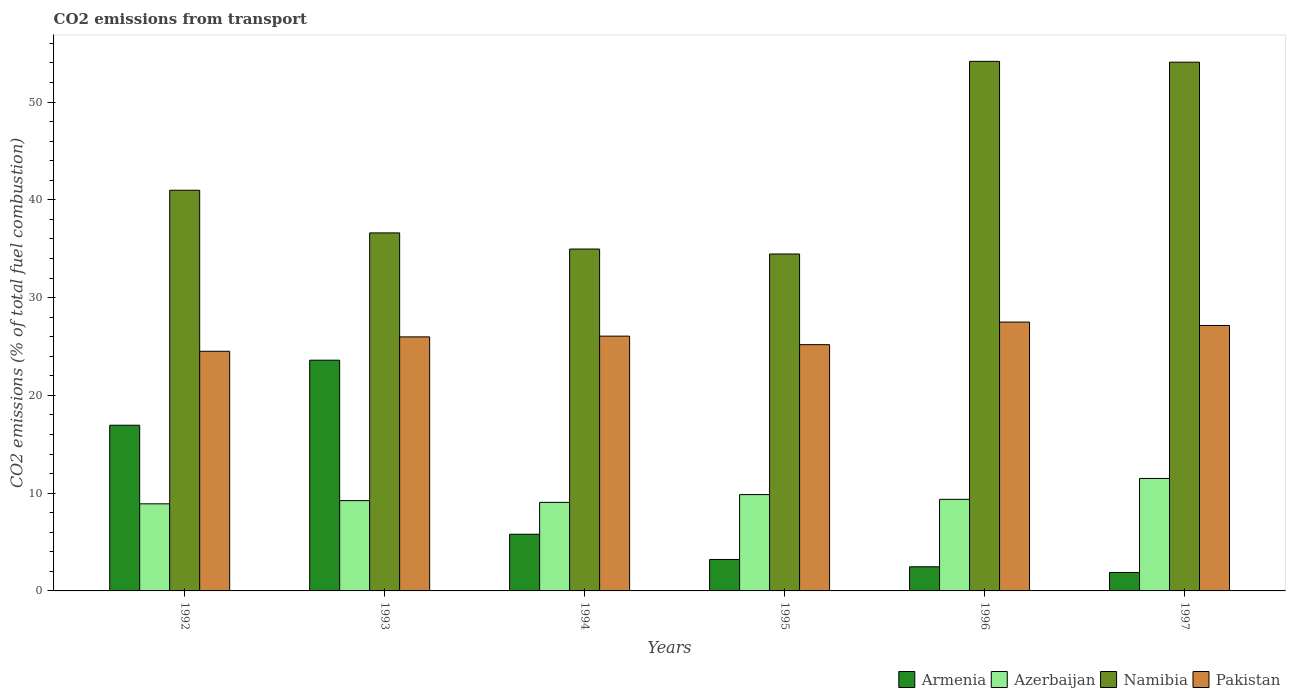How many different coloured bars are there?
Provide a succinct answer. 4. Are the number of bars per tick equal to the number of legend labels?
Make the answer very short. Yes. Are the number of bars on each tick of the X-axis equal?
Make the answer very short. Yes. How many bars are there on the 5th tick from the left?
Provide a succinct answer. 4. What is the total CO2 emitted in Azerbaijan in 1995?
Provide a short and direct response. 9.85. Across all years, what is the maximum total CO2 emitted in Azerbaijan?
Make the answer very short. 11.5. Across all years, what is the minimum total CO2 emitted in Namibia?
Provide a succinct answer. 34.46. In which year was the total CO2 emitted in Armenia minimum?
Offer a terse response. 1997. What is the total total CO2 emitted in Armenia in the graph?
Keep it short and to the point. 53.92. What is the difference between the total CO2 emitted in Pakistan in 1993 and that in 1997?
Give a very brief answer. -1.17. What is the difference between the total CO2 emitted in Namibia in 1996 and the total CO2 emitted in Azerbaijan in 1994?
Ensure brevity in your answer.  45.11. What is the average total CO2 emitted in Namibia per year?
Your answer should be very brief. 42.55. In the year 1995, what is the difference between the total CO2 emitted in Pakistan and total CO2 emitted in Namibia?
Offer a very short reply. -9.27. In how many years, is the total CO2 emitted in Pakistan greater than 54?
Ensure brevity in your answer.  0. What is the ratio of the total CO2 emitted in Armenia in 1993 to that in 1994?
Keep it short and to the point. 4.07. Is the total CO2 emitted in Namibia in 1993 less than that in 1995?
Give a very brief answer. No. What is the difference between the highest and the second highest total CO2 emitted in Namibia?
Keep it short and to the point. 0.09. What is the difference between the highest and the lowest total CO2 emitted in Armenia?
Offer a terse response. 21.71. What does the 1st bar from the left in 1994 represents?
Provide a succinct answer. Armenia. What does the 2nd bar from the right in 1997 represents?
Make the answer very short. Namibia. How many years are there in the graph?
Make the answer very short. 6. Does the graph contain any zero values?
Offer a terse response. No. Does the graph contain grids?
Provide a short and direct response. No. Where does the legend appear in the graph?
Keep it short and to the point. Bottom right. What is the title of the graph?
Keep it short and to the point. CO2 emissions from transport. What is the label or title of the Y-axis?
Your response must be concise. CO2 emissions (% of total fuel combustion). What is the CO2 emissions (% of total fuel combustion) in Armenia in 1992?
Make the answer very short. 16.95. What is the CO2 emissions (% of total fuel combustion) in Azerbaijan in 1992?
Keep it short and to the point. 8.91. What is the CO2 emissions (% of total fuel combustion) of Namibia in 1992?
Offer a terse response. 40.98. What is the CO2 emissions (% of total fuel combustion) of Pakistan in 1992?
Provide a short and direct response. 24.51. What is the CO2 emissions (% of total fuel combustion) of Armenia in 1993?
Provide a short and direct response. 23.6. What is the CO2 emissions (% of total fuel combustion) in Azerbaijan in 1993?
Keep it short and to the point. 9.24. What is the CO2 emissions (% of total fuel combustion) in Namibia in 1993?
Keep it short and to the point. 36.62. What is the CO2 emissions (% of total fuel combustion) of Pakistan in 1993?
Your answer should be compact. 25.98. What is the CO2 emissions (% of total fuel combustion) in Armenia in 1994?
Provide a succinct answer. 5.8. What is the CO2 emissions (% of total fuel combustion) in Azerbaijan in 1994?
Offer a terse response. 9.06. What is the CO2 emissions (% of total fuel combustion) in Namibia in 1994?
Make the answer very short. 34.97. What is the CO2 emissions (% of total fuel combustion) of Pakistan in 1994?
Keep it short and to the point. 26.06. What is the CO2 emissions (% of total fuel combustion) of Armenia in 1995?
Your answer should be very brief. 3.22. What is the CO2 emissions (% of total fuel combustion) in Azerbaijan in 1995?
Your answer should be very brief. 9.85. What is the CO2 emissions (% of total fuel combustion) of Namibia in 1995?
Your response must be concise. 34.46. What is the CO2 emissions (% of total fuel combustion) of Pakistan in 1995?
Your answer should be very brief. 25.19. What is the CO2 emissions (% of total fuel combustion) in Armenia in 1996?
Keep it short and to the point. 2.47. What is the CO2 emissions (% of total fuel combustion) in Azerbaijan in 1996?
Give a very brief answer. 9.37. What is the CO2 emissions (% of total fuel combustion) in Namibia in 1996?
Your answer should be compact. 54.17. What is the CO2 emissions (% of total fuel combustion) of Pakistan in 1996?
Your answer should be compact. 27.5. What is the CO2 emissions (% of total fuel combustion) in Armenia in 1997?
Ensure brevity in your answer.  1.89. What is the CO2 emissions (% of total fuel combustion) in Azerbaijan in 1997?
Offer a very short reply. 11.5. What is the CO2 emissions (% of total fuel combustion) in Namibia in 1997?
Offer a very short reply. 54.08. What is the CO2 emissions (% of total fuel combustion) of Pakistan in 1997?
Offer a terse response. 27.15. Across all years, what is the maximum CO2 emissions (% of total fuel combustion) in Armenia?
Give a very brief answer. 23.6. Across all years, what is the maximum CO2 emissions (% of total fuel combustion) of Azerbaijan?
Your answer should be very brief. 11.5. Across all years, what is the maximum CO2 emissions (% of total fuel combustion) in Namibia?
Offer a terse response. 54.17. Across all years, what is the maximum CO2 emissions (% of total fuel combustion) of Pakistan?
Keep it short and to the point. 27.5. Across all years, what is the minimum CO2 emissions (% of total fuel combustion) in Armenia?
Your answer should be very brief. 1.89. Across all years, what is the minimum CO2 emissions (% of total fuel combustion) of Azerbaijan?
Ensure brevity in your answer.  8.91. Across all years, what is the minimum CO2 emissions (% of total fuel combustion) in Namibia?
Your answer should be compact. 34.46. Across all years, what is the minimum CO2 emissions (% of total fuel combustion) in Pakistan?
Provide a succinct answer. 24.51. What is the total CO2 emissions (% of total fuel combustion) of Armenia in the graph?
Ensure brevity in your answer.  53.92. What is the total CO2 emissions (% of total fuel combustion) of Azerbaijan in the graph?
Your response must be concise. 57.93. What is the total CO2 emissions (% of total fuel combustion) in Namibia in the graph?
Your answer should be compact. 255.28. What is the total CO2 emissions (% of total fuel combustion) in Pakistan in the graph?
Offer a very short reply. 156.4. What is the difference between the CO2 emissions (% of total fuel combustion) in Armenia in 1992 and that in 1993?
Provide a short and direct response. -6.65. What is the difference between the CO2 emissions (% of total fuel combustion) in Azerbaijan in 1992 and that in 1993?
Your answer should be compact. -0.33. What is the difference between the CO2 emissions (% of total fuel combustion) of Namibia in 1992 and that in 1993?
Your answer should be very brief. 4.36. What is the difference between the CO2 emissions (% of total fuel combustion) of Pakistan in 1992 and that in 1993?
Your response must be concise. -1.47. What is the difference between the CO2 emissions (% of total fuel combustion) of Armenia in 1992 and that in 1994?
Provide a short and direct response. 11.15. What is the difference between the CO2 emissions (% of total fuel combustion) of Azerbaijan in 1992 and that in 1994?
Provide a short and direct response. -0.15. What is the difference between the CO2 emissions (% of total fuel combustion) in Namibia in 1992 and that in 1994?
Offer a terse response. 6.01. What is the difference between the CO2 emissions (% of total fuel combustion) of Pakistan in 1992 and that in 1994?
Provide a succinct answer. -1.55. What is the difference between the CO2 emissions (% of total fuel combustion) of Armenia in 1992 and that in 1995?
Your answer should be very brief. 13.73. What is the difference between the CO2 emissions (% of total fuel combustion) of Azerbaijan in 1992 and that in 1995?
Give a very brief answer. -0.94. What is the difference between the CO2 emissions (% of total fuel combustion) in Namibia in 1992 and that in 1995?
Make the answer very short. 6.52. What is the difference between the CO2 emissions (% of total fuel combustion) in Pakistan in 1992 and that in 1995?
Your answer should be very brief. -0.68. What is the difference between the CO2 emissions (% of total fuel combustion) in Armenia in 1992 and that in 1996?
Your answer should be very brief. 14.48. What is the difference between the CO2 emissions (% of total fuel combustion) in Azerbaijan in 1992 and that in 1996?
Offer a terse response. -0.46. What is the difference between the CO2 emissions (% of total fuel combustion) of Namibia in 1992 and that in 1996?
Offer a very short reply. -13.18. What is the difference between the CO2 emissions (% of total fuel combustion) in Pakistan in 1992 and that in 1996?
Make the answer very short. -2.99. What is the difference between the CO2 emissions (% of total fuel combustion) in Armenia in 1992 and that in 1997?
Provide a short and direct response. 15.06. What is the difference between the CO2 emissions (% of total fuel combustion) in Azerbaijan in 1992 and that in 1997?
Your response must be concise. -2.6. What is the difference between the CO2 emissions (% of total fuel combustion) in Namibia in 1992 and that in 1997?
Ensure brevity in your answer.  -13.1. What is the difference between the CO2 emissions (% of total fuel combustion) of Pakistan in 1992 and that in 1997?
Offer a terse response. -2.64. What is the difference between the CO2 emissions (% of total fuel combustion) in Armenia in 1993 and that in 1994?
Keep it short and to the point. 17.8. What is the difference between the CO2 emissions (% of total fuel combustion) of Azerbaijan in 1993 and that in 1994?
Your answer should be very brief. 0.18. What is the difference between the CO2 emissions (% of total fuel combustion) of Namibia in 1993 and that in 1994?
Make the answer very short. 1.65. What is the difference between the CO2 emissions (% of total fuel combustion) in Pakistan in 1993 and that in 1994?
Your answer should be very brief. -0.08. What is the difference between the CO2 emissions (% of total fuel combustion) in Armenia in 1993 and that in 1995?
Provide a short and direct response. 20.38. What is the difference between the CO2 emissions (% of total fuel combustion) in Azerbaijan in 1993 and that in 1995?
Provide a succinct answer. -0.62. What is the difference between the CO2 emissions (% of total fuel combustion) in Namibia in 1993 and that in 1995?
Ensure brevity in your answer.  2.16. What is the difference between the CO2 emissions (% of total fuel combustion) in Pakistan in 1993 and that in 1995?
Make the answer very short. 0.8. What is the difference between the CO2 emissions (% of total fuel combustion) of Armenia in 1993 and that in 1996?
Provide a short and direct response. 21.13. What is the difference between the CO2 emissions (% of total fuel combustion) in Azerbaijan in 1993 and that in 1996?
Provide a short and direct response. -0.13. What is the difference between the CO2 emissions (% of total fuel combustion) in Namibia in 1993 and that in 1996?
Offer a terse response. -17.55. What is the difference between the CO2 emissions (% of total fuel combustion) in Pakistan in 1993 and that in 1996?
Your answer should be compact. -1.51. What is the difference between the CO2 emissions (% of total fuel combustion) in Armenia in 1993 and that in 1997?
Provide a succinct answer. 21.71. What is the difference between the CO2 emissions (% of total fuel combustion) in Azerbaijan in 1993 and that in 1997?
Offer a very short reply. -2.27. What is the difference between the CO2 emissions (% of total fuel combustion) of Namibia in 1993 and that in 1997?
Provide a succinct answer. -17.46. What is the difference between the CO2 emissions (% of total fuel combustion) of Pakistan in 1993 and that in 1997?
Make the answer very short. -1.17. What is the difference between the CO2 emissions (% of total fuel combustion) in Armenia in 1994 and that in 1995?
Your answer should be very brief. 2.58. What is the difference between the CO2 emissions (% of total fuel combustion) in Azerbaijan in 1994 and that in 1995?
Provide a short and direct response. -0.79. What is the difference between the CO2 emissions (% of total fuel combustion) in Namibia in 1994 and that in 1995?
Your answer should be very brief. 0.51. What is the difference between the CO2 emissions (% of total fuel combustion) in Pakistan in 1994 and that in 1995?
Your response must be concise. 0.87. What is the difference between the CO2 emissions (% of total fuel combustion) of Armenia in 1994 and that in 1996?
Offer a very short reply. 3.33. What is the difference between the CO2 emissions (% of total fuel combustion) of Azerbaijan in 1994 and that in 1996?
Keep it short and to the point. -0.31. What is the difference between the CO2 emissions (% of total fuel combustion) of Namibia in 1994 and that in 1996?
Provide a short and direct response. -19.2. What is the difference between the CO2 emissions (% of total fuel combustion) in Pakistan in 1994 and that in 1996?
Provide a succinct answer. -1.44. What is the difference between the CO2 emissions (% of total fuel combustion) of Armenia in 1994 and that in 1997?
Your answer should be very brief. 3.91. What is the difference between the CO2 emissions (% of total fuel combustion) of Azerbaijan in 1994 and that in 1997?
Your answer should be compact. -2.45. What is the difference between the CO2 emissions (% of total fuel combustion) of Namibia in 1994 and that in 1997?
Your answer should be compact. -19.11. What is the difference between the CO2 emissions (% of total fuel combustion) of Pakistan in 1994 and that in 1997?
Provide a succinct answer. -1.09. What is the difference between the CO2 emissions (% of total fuel combustion) of Armenia in 1995 and that in 1996?
Offer a very short reply. 0.75. What is the difference between the CO2 emissions (% of total fuel combustion) in Azerbaijan in 1995 and that in 1996?
Offer a very short reply. 0.49. What is the difference between the CO2 emissions (% of total fuel combustion) in Namibia in 1995 and that in 1996?
Provide a succinct answer. -19.7. What is the difference between the CO2 emissions (% of total fuel combustion) of Pakistan in 1995 and that in 1996?
Provide a succinct answer. -2.31. What is the difference between the CO2 emissions (% of total fuel combustion) in Armenia in 1995 and that in 1997?
Your answer should be compact. 1.33. What is the difference between the CO2 emissions (% of total fuel combustion) in Azerbaijan in 1995 and that in 1997?
Make the answer very short. -1.65. What is the difference between the CO2 emissions (% of total fuel combustion) of Namibia in 1995 and that in 1997?
Offer a terse response. -19.62. What is the difference between the CO2 emissions (% of total fuel combustion) of Pakistan in 1995 and that in 1997?
Ensure brevity in your answer.  -1.96. What is the difference between the CO2 emissions (% of total fuel combustion) in Armenia in 1996 and that in 1997?
Offer a terse response. 0.58. What is the difference between the CO2 emissions (% of total fuel combustion) of Azerbaijan in 1996 and that in 1997?
Make the answer very short. -2.14. What is the difference between the CO2 emissions (% of total fuel combustion) in Namibia in 1996 and that in 1997?
Your answer should be compact. 0.09. What is the difference between the CO2 emissions (% of total fuel combustion) in Pakistan in 1996 and that in 1997?
Offer a terse response. 0.35. What is the difference between the CO2 emissions (% of total fuel combustion) in Armenia in 1992 and the CO2 emissions (% of total fuel combustion) in Azerbaijan in 1993?
Ensure brevity in your answer.  7.71. What is the difference between the CO2 emissions (% of total fuel combustion) of Armenia in 1992 and the CO2 emissions (% of total fuel combustion) of Namibia in 1993?
Ensure brevity in your answer.  -19.67. What is the difference between the CO2 emissions (% of total fuel combustion) in Armenia in 1992 and the CO2 emissions (% of total fuel combustion) in Pakistan in 1993?
Your answer should be compact. -9.04. What is the difference between the CO2 emissions (% of total fuel combustion) in Azerbaijan in 1992 and the CO2 emissions (% of total fuel combustion) in Namibia in 1993?
Offer a terse response. -27.71. What is the difference between the CO2 emissions (% of total fuel combustion) in Azerbaijan in 1992 and the CO2 emissions (% of total fuel combustion) in Pakistan in 1993?
Your response must be concise. -17.07. What is the difference between the CO2 emissions (% of total fuel combustion) of Namibia in 1992 and the CO2 emissions (% of total fuel combustion) of Pakistan in 1993?
Your response must be concise. 15. What is the difference between the CO2 emissions (% of total fuel combustion) of Armenia in 1992 and the CO2 emissions (% of total fuel combustion) of Azerbaijan in 1994?
Your response must be concise. 7.89. What is the difference between the CO2 emissions (% of total fuel combustion) in Armenia in 1992 and the CO2 emissions (% of total fuel combustion) in Namibia in 1994?
Provide a succinct answer. -18.02. What is the difference between the CO2 emissions (% of total fuel combustion) in Armenia in 1992 and the CO2 emissions (% of total fuel combustion) in Pakistan in 1994?
Provide a succinct answer. -9.11. What is the difference between the CO2 emissions (% of total fuel combustion) in Azerbaijan in 1992 and the CO2 emissions (% of total fuel combustion) in Namibia in 1994?
Make the answer very short. -26.06. What is the difference between the CO2 emissions (% of total fuel combustion) of Azerbaijan in 1992 and the CO2 emissions (% of total fuel combustion) of Pakistan in 1994?
Your response must be concise. -17.15. What is the difference between the CO2 emissions (% of total fuel combustion) in Namibia in 1992 and the CO2 emissions (% of total fuel combustion) in Pakistan in 1994?
Offer a very short reply. 14.92. What is the difference between the CO2 emissions (% of total fuel combustion) of Armenia in 1992 and the CO2 emissions (% of total fuel combustion) of Azerbaijan in 1995?
Your answer should be compact. 7.1. What is the difference between the CO2 emissions (% of total fuel combustion) in Armenia in 1992 and the CO2 emissions (% of total fuel combustion) in Namibia in 1995?
Give a very brief answer. -17.52. What is the difference between the CO2 emissions (% of total fuel combustion) of Armenia in 1992 and the CO2 emissions (% of total fuel combustion) of Pakistan in 1995?
Keep it short and to the point. -8.24. What is the difference between the CO2 emissions (% of total fuel combustion) of Azerbaijan in 1992 and the CO2 emissions (% of total fuel combustion) of Namibia in 1995?
Your answer should be very brief. -25.55. What is the difference between the CO2 emissions (% of total fuel combustion) in Azerbaijan in 1992 and the CO2 emissions (% of total fuel combustion) in Pakistan in 1995?
Offer a terse response. -16.28. What is the difference between the CO2 emissions (% of total fuel combustion) of Namibia in 1992 and the CO2 emissions (% of total fuel combustion) of Pakistan in 1995?
Ensure brevity in your answer.  15.79. What is the difference between the CO2 emissions (% of total fuel combustion) of Armenia in 1992 and the CO2 emissions (% of total fuel combustion) of Azerbaijan in 1996?
Offer a terse response. 7.58. What is the difference between the CO2 emissions (% of total fuel combustion) in Armenia in 1992 and the CO2 emissions (% of total fuel combustion) in Namibia in 1996?
Offer a very short reply. -37.22. What is the difference between the CO2 emissions (% of total fuel combustion) of Armenia in 1992 and the CO2 emissions (% of total fuel combustion) of Pakistan in 1996?
Your answer should be very brief. -10.55. What is the difference between the CO2 emissions (% of total fuel combustion) in Azerbaijan in 1992 and the CO2 emissions (% of total fuel combustion) in Namibia in 1996?
Your response must be concise. -45.26. What is the difference between the CO2 emissions (% of total fuel combustion) in Azerbaijan in 1992 and the CO2 emissions (% of total fuel combustion) in Pakistan in 1996?
Your answer should be compact. -18.59. What is the difference between the CO2 emissions (% of total fuel combustion) in Namibia in 1992 and the CO2 emissions (% of total fuel combustion) in Pakistan in 1996?
Your answer should be very brief. 13.48. What is the difference between the CO2 emissions (% of total fuel combustion) in Armenia in 1992 and the CO2 emissions (% of total fuel combustion) in Azerbaijan in 1997?
Your answer should be compact. 5.44. What is the difference between the CO2 emissions (% of total fuel combustion) of Armenia in 1992 and the CO2 emissions (% of total fuel combustion) of Namibia in 1997?
Offer a very short reply. -37.13. What is the difference between the CO2 emissions (% of total fuel combustion) of Armenia in 1992 and the CO2 emissions (% of total fuel combustion) of Pakistan in 1997?
Provide a short and direct response. -10.2. What is the difference between the CO2 emissions (% of total fuel combustion) in Azerbaijan in 1992 and the CO2 emissions (% of total fuel combustion) in Namibia in 1997?
Your answer should be very brief. -45.17. What is the difference between the CO2 emissions (% of total fuel combustion) in Azerbaijan in 1992 and the CO2 emissions (% of total fuel combustion) in Pakistan in 1997?
Ensure brevity in your answer.  -18.24. What is the difference between the CO2 emissions (% of total fuel combustion) of Namibia in 1992 and the CO2 emissions (% of total fuel combustion) of Pakistan in 1997?
Your response must be concise. 13.83. What is the difference between the CO2 emissions (% of total fuel combustion) of Armenia in 1993 and the CO2 emissions (% of total fuel combustion) of Azerbaijan in 1994?
Your answer should be very brief. 14.54. What is the difference between the CO2 emissions (% of total fuel combustion) in Armenia in 1993 and the CO2 emissions (% of total fuel combustion) in Namibia in 1994?
Offer a terse response. -11.37. What is the difference between the CO2 emissions (% of total fuel combustion) in Armenia in 1993 and the CO2 emissions (% of total fuel combustion) in Pakistan in 1994?
Keep it short and to the point. -2.46. What is the difference between the CO2 emissions (% of total fuel combustion) in Azerbaijan in 1993 and the CO2 emissions (% of total fuel combustion) in Namibia in 1994?
Give a very brief answer. -25.73. What is the difference between the CO2 emissions (% of total fuel combustion) in Azerbaijan in 1993 and the CO2 emissions (% of total fuel combustion) in Pakistan in 1994?
Give a very brief answer. -16.82. What is the difference between the CO2 emissions (% of total fuel combustion) in Namibia in 1993 and the CO2 emissions (% of total fuel combustion) in Pakistan in 1994?
Ensure brevity in your answer.  10.56. What is the difference between the CO2 emissions (% of total fuel combustion) of Armenia in 1993 and the CO2 emissions (% of total fuel combustion) of Azerbaijan in 1995?
Make the answer very short. 13.75. What is the difference between the CO2 emissions (% of total fuel combustion) of Armenia in 1993 and the CO2 emissions (% of total fuel combustion) of Namibia in 1995?
Keep it short and to the point. -10.86. What is the difference between the CO2 emissions (% of total fuel combustion) of Armenia in 1993 and the CO2 emissions (% of total fuel combustion) of Pakistan in 1995?
Your response must be concise. -1.59. What is the difference between the CO2 emissions (% of total fuel combustion) in Azerbaijan in 1993 and the CO2 emissions (% of total fuel combustion) in Namibia in 1995?
Give a very brief answer. -25.23. What is the difference between the CO2 emissions (% of total fuel combustion) of Azerbaijan in 1993 and the CO2 emissions (% of total fuel combustion) of Pakistan in 1995?
Offer a terse response. -15.95. What is the difference between the CO2 emissions (% of total fuel combustion) in Namibia in 1993 and the CO2 emissions (% of total fuel combustion) in Pakistan in 1995?
Ensure brevity in your answer.  11.43. What is the difference between the CO2 emissions (% of total fuel combustion) in Armenia in 1993 and the CO2 emissions (% of total fuel combustion) in Azerbaijan in 1996?
Make the answer very short. 14.23. What is the difference between the CO2 emissions (% of total fuel combustion) in Armenia in 1993 and the CO2 emissions (% of total fuel combustion) in Namibia in 1996?
Offer a very short reply. -30.57. What is the difference between the CO2 emissions (% of total fuel combustion) of Armenia in 1993 and the CO2 emissions (% of total fuel combustion) of Pakistan in 1996?
Provide a succinct answer. -3.9. What is the difference between the CO2 emissions (% of total fuel combustion) of Azerbaijan in 1993 and the CO2 emissions (% of total fuel combustion) of Namibia in 1996?
Make the answer very short. -44.93. What is the difference between the CO2 emissions (% of total fuel combustion) of Azerbaijan in 1993 and the CO2 emissions (% of total fuel combustion) of Pakistan in 1996?
Provide a succinct answer. -18.26. What is the difference between the CO2 emissions (% of total fuel combustion) in Namibia in 1993 and the CO2 emissions (% of total fuel combustion) in Pakistan in 1996?
Your response must be concise. 9.12. What is the difference between the CO2 emissions (% of total fuel combustion) in Armenia in 1993 and the CO2 emissions (% of total fuel combustion) in Azerbaijan in 1997?
Ensure brevity in your answer.  12.1. What is the difference between the CO2 emissions (% of total fuel combustion) of Armenia in 1993 and the CO2 emissions (% of total fuel combustion) of Namibia in 1997?
Keep it short and to the point. -30.48. What is the difference between the CO2 emissions (% of total fuel combustion) in Armenia in 1993 and the CO2 emissions (% of total fuel combustion) in Pakistan in 1997?
Offer a terse response. -3.55. What is the difference between the CO2 emissions (% of total fuel combustion) in Azerbaijan in 1993 and the CO2 emissions (% of total fuel combustion) in Namibia in 1997?
Offer a very short reply. -44.84. What is the difference between the CO2 emissions (% of total fuel combustion) of Azerbaijan in 1993 and the CO2 emissions (% of total fuel combustion) of Pakistan in 1997?
Make the answer very short. -17.91. What is the difference between the CO2 emissions (% of total fuel combustion) of Namibia in 1993 and the CO2 emissions (% of total fuel combustion) of Pakistan in 1997?
Keep it short and to the point. 9.47. What is the difference between the CO2 emissions (% of total fuel combustion) in Armenia in 1994 and the CO2 emissions (% of total fuel combustion) in Azerbaijan in 1995?
Your answer should be compact. -4.06. What is the difference between the CO2 emissions (% of total fuel combustion) of Armenia in 1994 and the CO2 emissions (% of total fuel combustion) of Namibia in 1995?
Offer a terse response. -28.67. What is the difference between the CO2 emissions (% of total fuel combustion) of Armenia in 1994 and the CO2 emissions (% of total fuel combustion) of Pakistan in 1995?
Ensure brevity in your answer.  -19.39. What is the difference between the CO2 emissions (% of total fuel combustion) of Azerbaijan in 1994 and the CO2 emissions (% of total fuel combustion) of Namibia in 1995?
Provide a short and direct response. -25.41. What is the difference between the CO2 emissions (% of total fuel combustion) in Azerbaijan in 1994 and the CO2 emissions (% of total fuel combustion) in Pakistan in 1995?
Your answer should be compact. -16.13. What is the difference between the CO2 emissions (% of total fuel combustion) in Namibia in 1994 and the CO2 emissions (% of total fuel combustion) in Pakistan in 1995?
Provide a short and direct response. 9.78. What is the difference between the CO2 emissions (% of total fuel combustion) of Armenia in 1994 and the CO2 emissions (% of total fuel combustion) of Azerbaijan in 1996?
Offer a very short reply. -3.57. What is the difference between the CO2 emissions (% of total fuel combustion) in Armenia in 1994 and the CO2 emissions (% of total fuel combustion) in Namibia in 1996?
Offer a terse response. -48.37. What is the difference between the CO2 emissions (% of total fuel combustion) in Armenia in 1994 and the CO2 emissions (% of total fuel combustion) in Pakistan in 1996?
Give a very brief answer. -21.7. What is the difference between the CO2 emissions (% of total fuel combustion) of Azerbaijan in 1994 and the CO2 emissions (% of total fuel combustion) of Namibia in 1996?
Ensure brevity in your answer.  -45.11. What is the difference between the CO2 emissions (% of total fuel combustion) of Azerbaijan in 1994 and the CO2 emissions (% of total fuel combustion) of Pakistan in 1996?
Provide a short and direct response. -18.44. What is the difference between the CO2 emissions (% of total fuel combustion) of Namibia in 1994 and the CO2 emissions (% of total fuel combustion) of Pakistan in 1996?
Keep it short and to the point. 7.47. What is the difference between the CO2 emissions (% of total fuel combustion) in Armenia in 1994 and the CO2 emissions (% of total fuel combustion) in Azerbaijan in 1997?
Ensure brevity in your answer.  -5.71. What is the difference between the CO2 emissions (% of total fuel combustion) of Armenia in 1994 and the CO2 emissions (% of total fuel combustion) of Namibia in 1997?
Offer a terse response. -48.28. What is the difference between the CO2 emissions (% of total fuel combustion) of Armenia in 1994 and the CO2 emissions (% of total fuel combustion) of Pakistan in 1997?
Make the answer very short. -21.35. What is the difference between the CO2 emissions (% of total fuel combustion) of Azerbaijan in 1994 and the CO2 emissions (% of total fuel combustion) of Namibia in 1997?
Offer a terse response. -45.02. What is the difference between the CO2 emissions (% of total fuel combustion) in Azerbaijan in 1994 and the CO2 emissions (% of total fuel combustion) in Pakistan in 1997?
Provide a succinct answer. -18.09. What is the difference between the CO2 emissions (% of total fuel combustion) in Namibia in 1994 and the CO2 emissions (% of total fuel combustion) in Pakistan in 1997?
Offer a terse response. 7.82. What is the difference between the CO2 emissions (% of total fuel combustion) of Armenia in 1995 and the CO2 emissions (% of total fuel combustion) of Azerbaijan in 1996?
Offer a terse response. -6.15. What is the difference between the CO2 emissions (% of total fuel combustion) in Armenia in 1995 and the CO2 emissions (% of total fuel combustion) in Namibia in 1996?
Your answer should be compact. -50.95. What is the difference between the CO2 emissions (% of total fuel combustion) in Armenia in 1995 and the CO2 emissions (% of total fuel combustion) in Pakistan in 1996?
Keep it short and to the point. -24.28. What is the difference between the CO2 emissions (% of total fuel combustion) of Azerbaijan in 1995 and the CO2 emissions (% of total fuel combustion) of Namibia in 1996?
Offer a terse response. -44.31. What is the difference between the CO2 emissions (% of total fuel combustion) in Azerbaijan in 1995 and the CO2 emissions (% of total fuel combustion) in Pakistan in 1996?
Offer a terse response. -17.65. What is the difference between the CO2 emissions (% of total fuel combustion) in Namibia in 1995 and the CO2 emissions (% of total fuel combustion) in Pakistan in 1996?
Ensure brevity in your answer.  6.96. What is the difference between the CO2 emissions (% of total fuel combustion) in Armenia in 1995 and the CO2 emissions (% of total fuel combustion) in Azerbaijan in 1997?
Give a very brief answer. -8.29. What is the difference between the CO2 emissions (% of total fuel combustion) in Armenia in 1995 and the CO2 emissions (% of total fuel combustion) in Namibia in 1997?
Keep it short and to the point. -50.87. What is the difference between the CO2 emissions (% of total fuel combustion) in Armenia in 1995 and the CO2 emissions (% of total fuel combustion) in Pakistan in 1997?
Give a very brief answer. -23.93. What is the difference between the CO2 emissions (% of total fuel combustion) in Azerbaijan in 1995 and the CO2 emissions (% of total fuel combustion) in Namibia in 1997?
Your answer should be very brief. -44.23. What is the difference between the CO2 emissions (% of total fuel combustion) of Azerbaijan in 1995 and the CO2 emissions (% of total fuel combustion) of Pakistan in 1997?
Your answer should be compact. -17.3. What is the difference between the CO2 emissions (% of total fuel combustion) of Namibia in 1995 and the CO2 emissions (% of total fuel combustion) of Pakistan in 1997?
Your response must be concise. 7.31. What is the difference between the CO2 emissions (% of total fuel combustion) of Armenia in 1996 and the CO2 emissions (% of total fuel combustion) of Azerbaijan in 1997?
Your answer should be very brief. -9.04. What is the difference between the CO2 emissions (% of total fuel combustion) in Armenia in 1996 and the CO2 emissions (% of total fuel combustion) in Namibia in 1997?
Your answer should be compact. -51.61. What is the difference between the CO2 emissions (% of total fuel combustion) of Armenia in 1996 and the CO2 emissions (% of total fuel combustion) of Pakistan in 1997?
Your answer should be compact. -24.68. What is the difference between the CO2 emissions (% of total fuel combustion) of Azerbaijan in 1996 and the CO2 emissions (% of total fuel combustion) of Namibia in 1997?
Provide a succinct answer. -44.71. What is the difference between the CO2 emissions (% of total fuel combustion) in Azerbaijan in 1996 and the CO2 emissions (% of total fuel combustion) in Pakistan in 1997?
Your response must be concise. -17.78. What is the difference between the CO2 emissions (% of total fuel combustion) of Namibia in 1996 and the CO2 emissions (% of total fuel combustion) of Pakistan in 1997?
Your answer should be compact. 27.02. What is the average CO2 emissions (% of total fuel combustion) of Armenia per year?
Keep it short and to the point. 8.99. What is the average CO2 emissions (% of total fuel combustion) in Azerbaijan per year?
Give a very brief answer. 9.65. What is the average CO2 emissions (% of total fuel combustion) of Namibia per year?
Your answer should be compact. 42.55. What is the average CO2 emissions (% of total fuel combustion) in Pakistan per year?
Provide a succinct answer. 26.07. In the year 1992, what is the difference between the CO2 emissions (% of total fuel combustion) in Armenia and CO2 emissions (% of total fuel combustion) in Azerbaijan?
Offer a very short reply. 8.04. In the year 1992, what is the difference between the CO2 emissions (% of total fuel combustion) of Armenia and CO2 emissions (% of total fuel combustion) of Namibia?
Keep it short and to the point. -24.04. In the year 1992, what is the difference between the CO2 emissions (% of total fuel combustion) in Armenia and CO2 emissions (% of total fuel combustion) in Pakistan?
Your answer should be compact. -7.56. In the year 1992, what is the difference between the CO2 emissions (% of total fuel combustion) in Azerbaijan and CO2 emissions (% of total fuel combustion) in Namibia?
Provide a succinct answer. -32.07. In the year 1992, what is the difference between the CO2 emissions (% of total fuel combustion) in Azerbaijan and CO2 emissions (% of total fuel combustion) in Pakistan?
Give a very brief answer. -15.6. In the year 1992, what is the difference between the CO2 emissions (% of total fuel combustion) of Namibia and CO2 emissions (% of total fuel combustion) of Pakistan?
Provide a short and direct response. 16.47. In the year 1993, what is the difference between the CO2 emissions (% of total fuel combustion) in Armenia and CO2 emissions (% of total fuel combustion) in Azerbaijan?
Give a very brief answer. 14.36. In the year 1993, what is the difference between the CO2 emissions (% of total fuel combustion) in Armenia and CO2 emissions (% of total fuel combustion) in Namibia?
Ensure brevity in your answer.  -13.02. In the year 1993, what is the difference between the CO2 emissions (% of total fuel combustion) in Armenia and CO2 emissions (% of total fuel combustion) in Pakistan?
Your response must be concise. -2.38. In the year 1993, what is the difference between the CO2 emissions (% of total fuel combustion) in Azerbaijan and CO2 emissions (% of total fuel combustion) in Namibia?
Provide a succinct answer. -27.38. In the year 1993, what is the difference between the CO2 emissions (% of total fuel combustion) of Azerbaijan and CO2 emissions (% of total fuel combustion) of Pakistan?
Give a very brief answer. -16.75. In the year 1993, what is the difference between the CO2 emissions (% of total fuel combustion) in Namibia and CO2 emissions (% of total fuel combustion) in Pakistan?
Make the answer very short. 10.64. In the year 1994, what is the difference between the CO2 emissions (% of total fuel combustion) in Armenia and CO2 emissions (% of total fuel combustion) in Azerbaijan?
Offer a very short reply. -3.26. In the year 1994, what is the difference between the CO2 emissions (% of total fuel combustion) in Armenia and CO2 emissions (% of total fuel combustion) in Namibia?
Your response must be concise. -29.17. In the year 1994, what is the difference between the CO2 emissions (% of total fuel combustion) in Armenia and CO2 emissions (% of total fuel combustion) in Pakistan?
Ensure brevity in your answer.  -20.26. In the year 1994, what is the difference between the CO2 emissions (% of total fuel combustion) in Azerbaijan and CO2 emissions (% of total fuel combustion) in Namibia?
Make the answer very short. -25.91. In the year 1994, what is the difference between the CO2 emissions (% of total fuel combustion) in Azerbaijan and CO2 emissions (% of total fuel combustion) in Pakistan?
Keep it short and to the point. -17. In the year 1994, what is the difference between the CO2 emissions (% of total fuel combustion) of Namibia and CO2 emissions (% of total fuel combustion) of Pakistan?
Your response must be concise. 8.91. In the year 1995, what is the difference between the CO2 emissions (% of total fuel combustion) of Armenia and CO2 emissions (% of total fuel combustion) of Azerbaijan?
Provide a short and direct response. -6.64. In the year 1995, what is the difference between the CO2 emissions (% of total fuel combustion) in Armenia and CO2 emissions (% of total fuel combustion) in Namibia?
Ensure brevity in your answer.  -31.25. In the year 1995, what is the difference between the CO2 emissions (% of total fuel combustion) in Armenia and CO2 emissions (% of total fuel combustion) in Pakistan?
Provide a short and direct response. -21.97. In the year 1995, what is the difference between the CO2 emissions (% of total fuel combustion) in Azerbaijan and CO2 emissions (% of total fuel combustion) in Namibia?
Give a very brief answer. -24.61. In the year 1995, what is the difference between the CO2 emissions (% of total fuel combustion) in Azerbaijan and CO2 emissions (% of total fuel combustion) in Pakistan?
Give a very brief answer. -15.34. In the year 1995, what is the difference between the CO2 emissions (% of total fuel combustion) of Namibia and CO2 emissions (% of total fuel combustion) of Pakistan?
Give a very brief answer. 9.27. In the year 1996, what is the difference between the CO2 emissions (% of total fuel combustion) of Armenia and CO2 emissions (% of total fuel combustion) of Azerbaijan?
Make the answer very short. -6.9. In the year 1996, what is the difference between the CO2 emissions (% of total fuel combustion) in Armenia and CO2 emissions (% of total fuel combustion) in Namibia?
Keep it short and to the point. -51.7. In the year 1996, what is the difference between the CO2 emissions (% of total fuel combustion) of Armenia and CO2 emissions (% of total fuel combustion) of Pakistan?
Your answer should be very brief. -25.03. In the year 1996, what is the difference between the CO2 emissions (% of total fuel combustion) in Azerbaijan and CO2 emissions (% of total fuel combustion) in Namibia?
Your response must be concise. -44.8. In the year 1996, what is the difference between the CO2 emissions (% of total fuel combustion) in Azerbaijan and CO2 emissions (% of total fuel combustion) in Pakistan?
Make the answer very short. -18.13. In the year 1996, what is the difference between the CO2 emissions (% of total fuel combustion) of Namibia and CO2 emissions (% of total fuel combustion) of Pakistan?
Make the answer very short. 26.67. In the year 1997, what is the difference between the CO2 emissions (% of total fuel combustion) of Armenia and CO2 emissions (% of total fuel combustion) of Azerbaijan?
Your answer should be very brief. -9.62. In the year 1997, what is the difference between the CO2 emissions (% of total fuel combustion) of Armenia and CO2 emissions (% of total fuel combustion) of Namibia?
Offer a terse response. -52.19. In the year 1997, what is the difference between the CO2 emissions (% of total fuel combustion) in Armenia and CO2 emissions (% of total fuel combustion) in Pakistan?
Ensure brevity in your answer.  -25.26. In the year 1997, what is the difference between the CO2 emissions (% of total fuel combustion) in Azerbaijan and CO2 emissions (% of total fuel combustion) in Namibia?
Keep it short and to the point. -42.58. In the year 1997, what is the difference between the CO2 emissions (% of total fuel combustion) in Azerbaijan and CO2 emissions (% of total fuel combustion) in Pakistan?
Give a very brief answer. -15.65. In the year 1997, what is the difference between the CO2 emissions (% of total fuel combustion) in Namibia and CO2 emissions (% of total fuel combustion) in Pakistan?
Provide a short and direct response. 26.93. What is the ratio of the CO2 emissions (% of total fuel combustion) in Armenia in 1992 to that in 1993?
Your answer should be very brief. 0.72. What is the ratio of the CO2 emissions (% of total fuel combustion) of Azerbaijan in 1992 to that in 1993?
Your answer should be very brief. 0.96. What is the ratio of the CO2 emissions (% of total fuel combustion) of Namibia in 1992 to that in 1993?
Offer a terse response. 1.12. What is the ratio of the CO2 emissions (% of total fuel combustion) in Pakistan in 1992 to that in 1993?
Offer a terse response. 0.94. What is the ratio of the CO2 emissions (% of total fuel combustion) in Armenia in 1992 to that in 1994?
Provide a short and direct response. 2.92. What is the ratio of the CO2 emissions (% of total fuel combustion) in Azerbaijan in 1992 to that in 1994?
Make the answer very short. 0.98. What is the ratio of the CO2 emissions (% of total fuel combustion) in Namibia in 1992 to that in 1994?
Provide a succinct answer. 1.17. What is the ratio of the CO2 emissions (% of total fuel combustion) in Pakistan in 1992 to that in 1994?
Your answer should be compact. 0.94. What is the ratio of the CO2 emissions (% of total fuel combustion) of Armenia in 1992 to that in 1995?
Your answer should be very brief. 5.27. What is the ratio of the CO2 emissions (% of total fuel combustion) of Azerbaijan in 1992 to that in 1995?
Your response must be concise. 0.9. What is the ratio of the CO2 emissions (% of total fuel combustion) in Namibia in 1992 to that in 1995?
Provide a short and direct response. 1.19. What is the ratio of the CO2 emissions (% of total fuel combustion) of Pakistan in 1992 to that in 1995?
Your response must be concise. 0.97. What is the ratio of the CO2 emissions (% of total fuel combustion) in Armenia in 1992 to that in 1996?
Your answer should be compact. 6.86. What is the ratio of the CO2 emissions (% of total fuel combustion) in Azerbaijan in 1992 to that in 1996?
Offer a terse response. 0.95. What is the ratio of the CO2 emissions (% of total fuel combustion) in Namibia in 1992 to that in 1996?
Keep it short and to the point. 0.76. What is the ratio of the CO2 emissions (% of total fuel combustion) in Pakistan in 1992 to that in 1996?
Ensure brevity in your answer.  0.89. What is the ratio of the CO2 emissions (% of total fuel combustion) of Armenia in 1992 to that in 1997?
Your answer should be compact. 8.98. What is the ratio of the CO2 emissions (% of total fuel combustion) of Azerbaijan in 1992 to that in 1997?
Provide a short and direct response. 0.77. What is the ratio of the CO2 emissions (% of total fuel combustion) of Namibia in 1992 to that in 1997?
Offer a terse response. 0.76. What is the ratio of the CO2 emissions (% of total fuel combustion) in Pakistan in 1992 to that in 1997?
Your answer should be very brief. 0.9. What is the ratio of the CO2 emissions (% of total fuel combustion) in Armenia in 1993 to that in 1994?
Provide a short and direct response. 4.07. What is the ratio of the CO2 emissions (% of total fuel combustion) of Azerbaijan in 1993 to that in 1994?
Make the answer very short. 1.02. What is the ratio of the CO2 emissions (% of total fuel combustion) of Namibia in 1993 to that in 1994?
Keep it short and to the point. 1.05. What is the ratio of the CO2 emissions (% of total fuel combustion) of Pakistan in 1993 to that in 1994?
Your answer should be very brief. 1. What is the ratio of the CO2 emissions (% of total fuel combustion) in Armenia in 1993 to that in 1995?
Your response must be concise. 7.34. What is the ratio of the CO2 emissions (% of total fuel combustion) in Azerbaijan in 1993 to that in 1995?
Keep it short and to the point. 0.94. What is the ratio of the CO2 emissions (% of total fuel combustion) in Namibia in 1993 to that in 1995?
Give a very brief answer. 1.06. What is the ratio of the CO2 emissions (% of total fuel combustion) in Pakistan in 1993 to that in 1995?
Ensure brevity in your answer.  1.03. What is the ratio of the CO2 emissions (% of total fuel combustion) of Armenia in 1993 to that in 1996?
Offer a very short reply. 9.56. What is the ratio of the CO2 emissions (% of total fuel combustion) in Azerbaijan in 1993 to that in 1996?
Your answer should be compact. 0.99. What is the ratio of the CO2 emissions (% of total fuel combustion) of Namibia in 1993 to that in 1996?
Offer a very short reply. 0.68. What is the ratio of the CO2 emissions (% of total fuel combustion) of Pakistan in 1993 to that in 1996?
Keep it short and to the point. 0.94. What is the ratio of the CO2 emissions (% of total fuel combustion) of Armenia in 1993 to that in 1997?
Your answer should be very brief. 12.51. What is the ratio of the CO2 emissions (% of total fuel combustion) in Azerbaijan in 1993 to that in 1997?
Your answer should be compact. 0.8. What is the ratio of the CO2 emissions (% of total fuel combustion) in Namibia in 1993 to that in 1997?
Give a very brief answer. 0.68. What is the ratio of the CO2 emissions (% of total fuel combustion) of Armenia in 1994 to that in 1995?
Ensure brevity in your answer.  1.8. What is the ratio of the CO2 emissions (% of total fuel combustion) of Azerbaijan in 1994 to that in 1995?
Offer a terse response. 0.92. What is the ratio of the CO2 emissions (% of total fuel combustion) of Namibia in 1994 to that in 1995?
Your answer should be very brief. 1.01. What is the ratio of the CO2 emissions (% of total fuel combustion) of Pakistan in 1994 to that in 1995?
Your response must be concise. 1.03. What is the ratio of the CO2 emissions (% of total fuel combustion) of Armenia in 1994 to that in 1996?
Your answer should be compact. 2.35. What is the ratio of the CO2 emissions (% of total fuel combustion) in Azerbaijan in 1994 to that in 1996?
Make the answer very short. 0.97. What is the ratio of the CO2 emissions (% of total fuel combustion) in Namibia in 1994 to that in 1996?
Offer a very short reply. 0.65. What is the ratio of the CO2 emissions (% of total fuel combustion) in Pakistan in 1994 to that in 1996?
Your answer should be very brief. 0.95. What is the ratio of the CO2 emissions (% of total fuel combustion) of Armenia in 1994 to that in 1997?
Your response must be concise. 3.07. What is the ratio of the CO2 emissions (% of total fuel combustion) in Azerbaijan in 1994 to that in 1997?
Provide a succinct answer. 0.79. What is the ratio of the CO2 emissions (% of total fuel combustion) of Namibia in 1994 to that in 1997?
Your answer should be compact. 0.65. What is the ratio of the CO2 emissions (% of total fuel combustion) in Pakistan in 1994 to that in 1997?
Your response must be concise. 0.96. What is the ratio of the CO2 emissions (% of total fuel combustion) of Armenia in 1995 to that in 1996?
Your response must be concise. 1.3. What is the ratio of the CO2 emissions (% of total fuel combustion) of Azerbaijan in 1995 to that in 1996?
Provide a succinct answer. 1.05. What is the ratio of the CO2 emissions (% of total fuel combustion) of Namibia in 1995 to that in 1996?
Your answer should be very brief. 0.64. What is the ratio of the CO2 emissions (% of total fuel combustion) of Pakistan in 1995 to that in 1996?
Your response must be concise. 0.92. What is the ratio of the CO2 emissions (% of total fuel combustion) of Armenia in 1995 to that in 1997?
Your response must be concise. 1.7. What is the ratio of the CO2 emissions (% of total fuel combustion) in Azerbaijan in 1995 to that in 1997?
Offer a very short reply. 0.86. What is the ratio of the CO2 emissions (% of total fuel combustion) in Namibia in 1995 to that in 1997?
Offer a very short reply. 0.64. What is the ratio of the CO2 emissions (% of total fuel combustion) in Pakistan in 1995 to that in 1997?
Your answer should be very brief. 0.93. What is the ratio of the CO2 emissions (% of total fuel combustion) of Armenia in 1996 to that in 1997?
Keep it short and to the point. 1.31. What is the ratio of the CO2 emissions (% of total fuel combustion) of Azerbaijan in 1996 to that in 1997?
Keep it short and to the point. 0.81. What is the ratio of the CO2 emissions (% of total fuel combustion) of Pakistan in 1996 to that in 1997?
Ensure brevity in your answer.  1.01. What is the difference between the highest and the second highest CO2 emissions (% of total fuel combustion) of Armenia?
Your response must be concise. 6.65. What is the difference between the highest and the second highest CO2 emissions (% of total fuel combustion) of Azerbaijan?
Provide a succinct answer. 1.65. What is the difference between the highest and the second highest CO2 emissions (% of total fuel combustion) in Namibia?
Your answer should be compact. 0.09. What is the difference between the highest and the second highest CO2 emissions (% of total fuel combustion) of Pakistan?
Give a very brief answer. 0.35. What is the difference between the highest and the lowest CO2 emissions (% of total fuel combustion) of Armenia?
Keep it short and to the point. 21.71. What is the difference between the highest and the lowest CO2 emissions (% of total fuel combustion) in Azerbaijan?
Your answer should be very brief. 2.6. What is the difference between the highest and the lowest CO2 emissions (% of total fuel combustion) of Namibia?
Keep it short and to the point. 19.7. What is the difference between the highest and the lowest CO2 emissions (% of total fuel combustion) in Pakistan?
Your response must be concise. 2.99. 